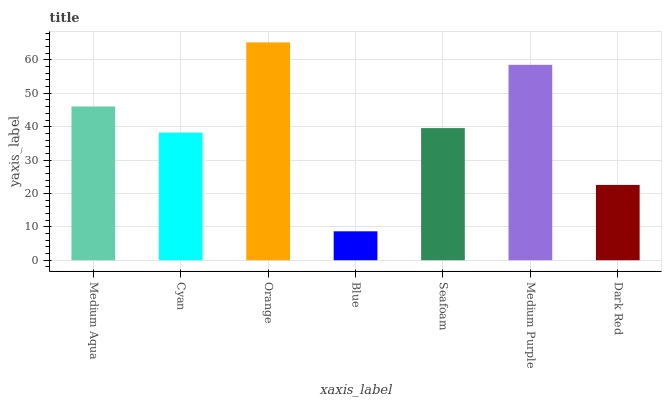Is Cyan the minimum?
Answer yes or no. No. Is Cyan the maximum?
Answer yes or no. No. Is Medium Aqua greater than Cyan?
Answer yes or no. Yes. Is Cyan less than Medium Aqua?
Answer yes or no. Yes. Is Cyan greater than Medium Aqua?
Answer yes or no. No. Is Medium Aqua less than Cyan?
Answer yes or no. No. Is Seafoam the high median?
Answer yes or no. Yes. Is Seafoam the low median?
Answer yes or no. Yes. Is Orange the high median?
Answer yes or no. No. Is Cyan the low median?
Answer yes or no. No. 